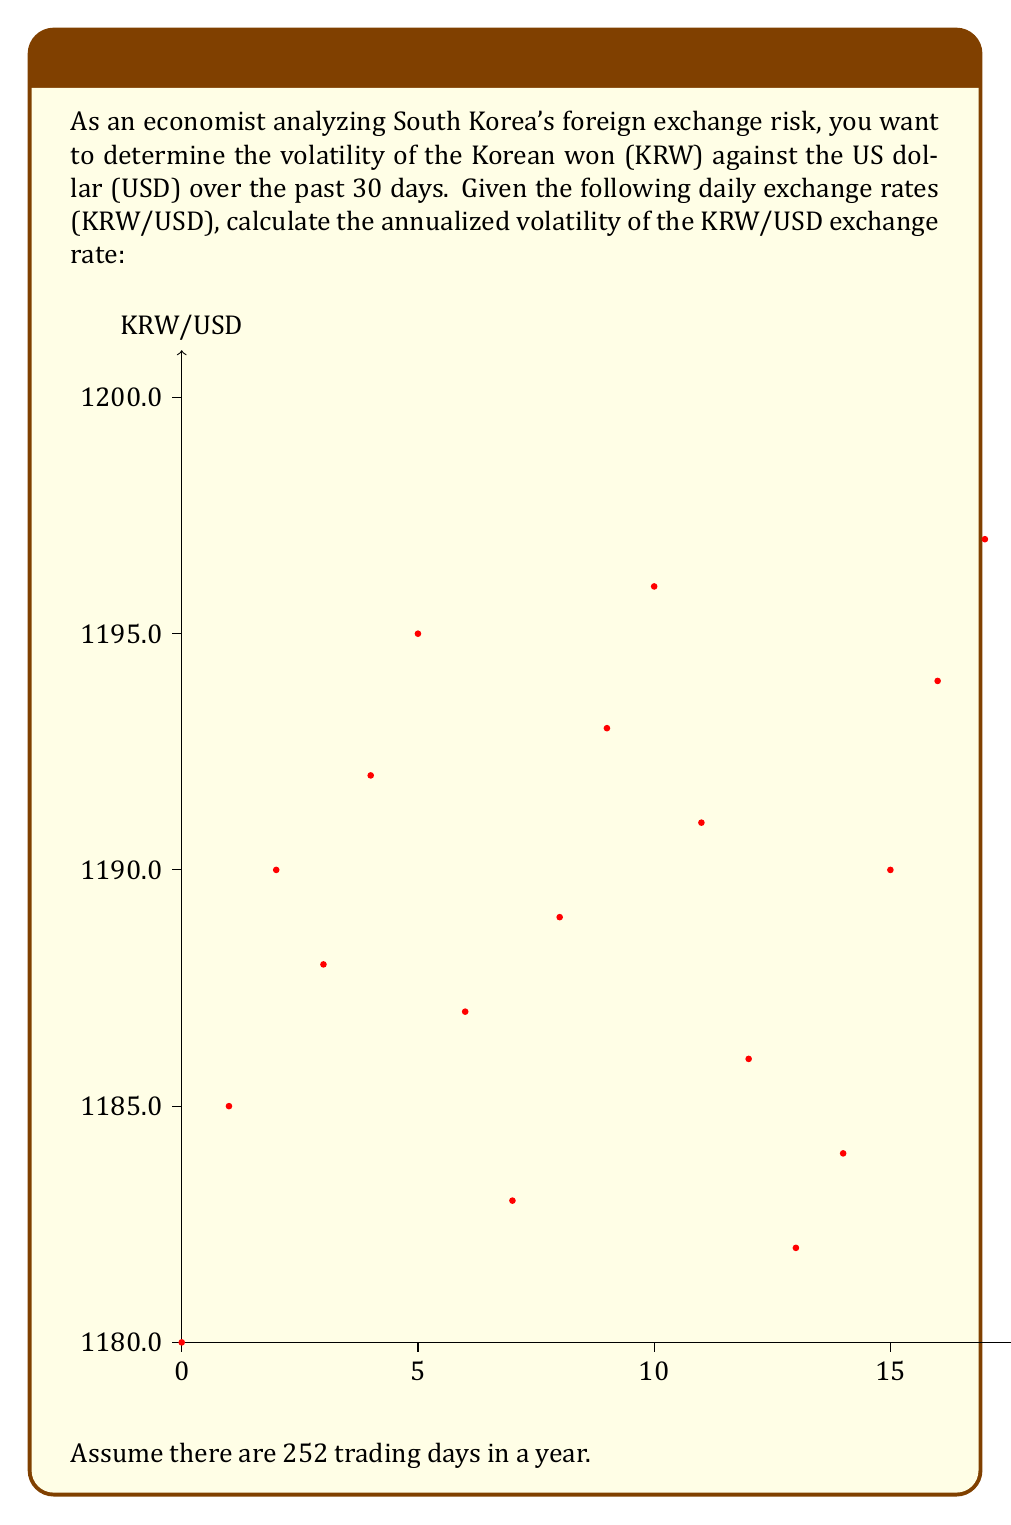What is the answer to this math problem? To calculate the annualized volatility, we'll follow these steps:

1) Calculate daily returns:
   $R_t = \ln(\frac{S_t}{S_{t-1}})$
   where $S_t$ is the exchange rate on day $t$.

2) Calculate the mean of daily returns:
   $\bar{R} = \frac{1}{n}\sum_{t=1}^n R_t$

3) Calculate the variance of daily returns:
   $\sigma^2 = \frac{1}{n-1}\sum_{t=1}^n (R_t - \bar{R})^2$

4) Calculate the standard deviation (daily volatility):
   $\sigma = \sqrt{\sigma^2}$

5) Annualize the volatility:
   $\sigma_{annual} = \sigma \times \sqrt{252}$

Let's perform these calculations:

1) Daily returns (showing first few):
   $R_1 = \ln(\frac{1185}{1180}) = 0.00423$
   $R_2 = \ln(\frac{1190}{1185}) = 0.00421$
   ...

2) Mean of daily returns:
   $\bar{R} = 0.000256$

3) Variance of daily returns:
   $\sigma^2 = 0.0000163$

4) Standard deviation (daily volatility):
   $\sigma = \sqrt{0.0000163} = 0.00404$

5) Annualized volatility:
   $\sigma_{annual} = 0.00404 \times \sqrt{252} = 0.0641$ or 6.41%
Answer: 6.41% 